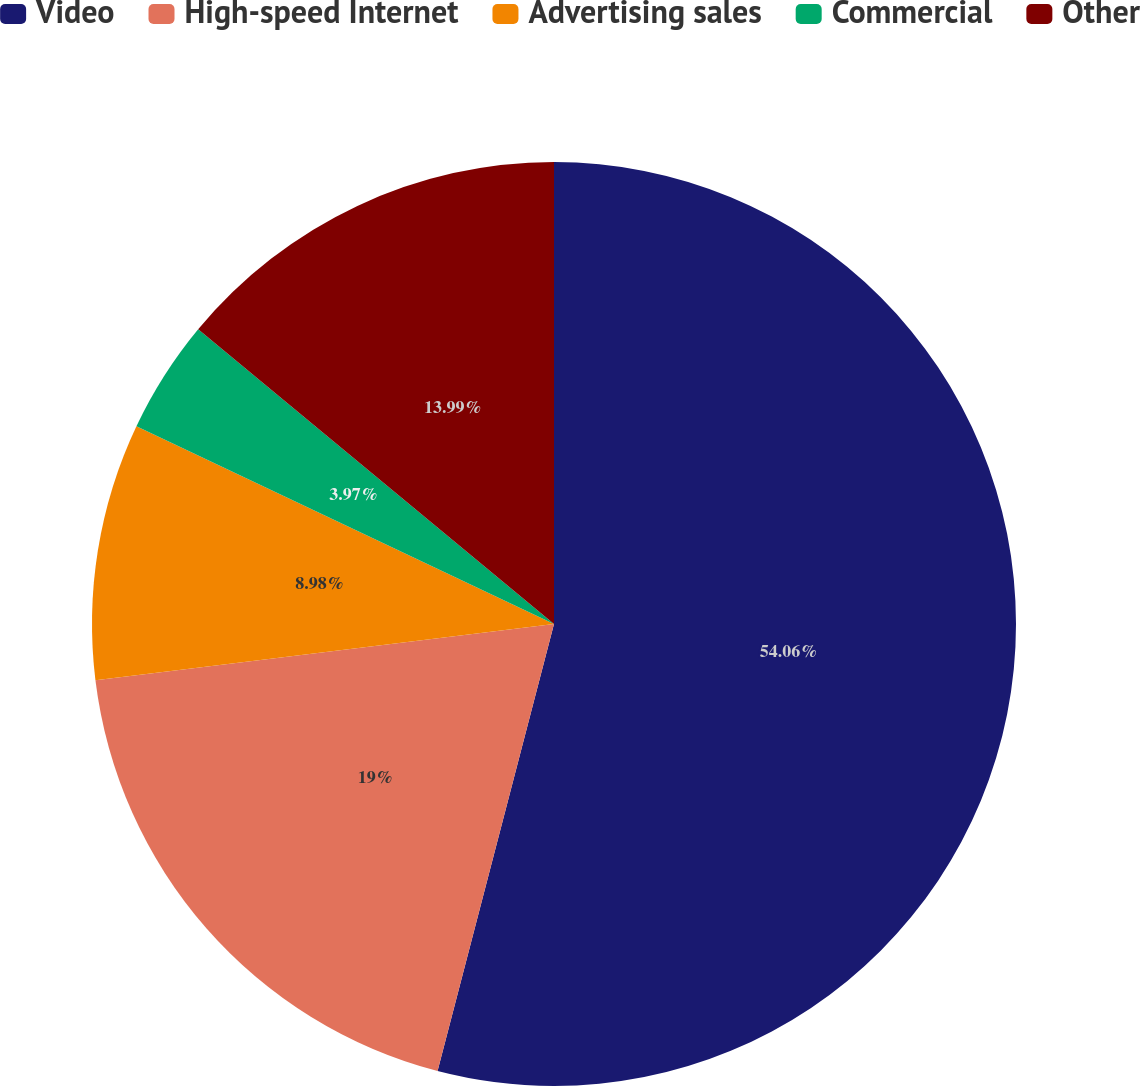Convert chart to OTSL. <chart><loc_0><loc_0><loc_500><loc_500><pie_chart><fcel>Video<fcel>High-speed Internet<fcel>Advertising sales<fcel>Commercial<fcel>Other<nl><fcel>54.05%<fcel>19.0%<fcel>8.98%<fcel>3.97%<fcel>13.99%<nl></chart> 